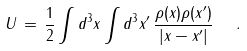<formula> <loc_0><loc_0><loc_500><loc_500>U \, = \, \frac { 1 } { 2 } \int d ^ { 3 } x \int d ^ { 3 } x ^ { \prime } \, \frac { \rho ( x ) \rho ( x ^ { \prime } ) } { | x - x ^ { \prime } | } \ \ .</formula> 